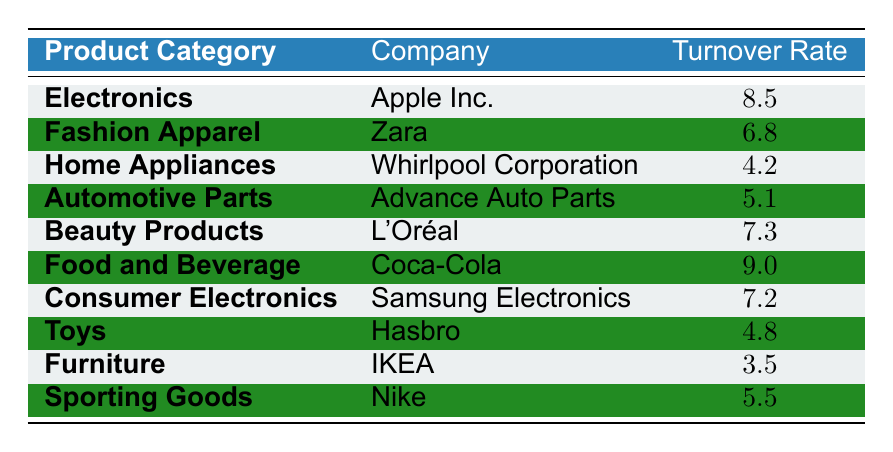What is the highest inventory turnover rate in the table? By examining the turnover rates listed in the table, the highest value is 9.0 from Coca-Cola in the Food and Beverage category.
Answer: 9.0 Which company has the lowest inventory turnover rate? The table shows that IKEA has the lowest turnover rate of 3.5 in the Furniture category.
Answer: IKEA What is the average inventory turnover rate for the product categories listed? To find the average, sum all the turnover rates (8.5 + 6.8 + 4.2 + 5.1 + 7.3 + 9.0 + 7.2 + 4.8 + 3.5 + 5.5) = 57.4, then divide by the number of categories (10). The average is 57.4 / 10 = 5.74.
Answer: 5.74 Does Zara have a higher inventory turnover rate than Whirlpool Corporation? Yes, Zara's turnover rate is 6.8, which is higher than Whirlpool Corporation's 4.2.
Answer: Yes What is the difference in turnover rate between the company with the highest and the lowest rates? The highest turnover rate is Coca-Cola at 9.0 and the lowest is IKEA at 3.5. The difference is 9.0 - 3.5 = 5.5.
Answer: 5.5 How many product categories have a turnover rate greater than 6? The product categories with rates greater than 6 are Electronics (8.5), Fashion Apparel (6.8), Beauty Products (7.3), Food and Beverage (9.0), and Consumer Electronics (7.2), counting to 5 categories in total.
Answer: 5 Which two companies have turnover rates within 0.5 of each other? By examining the rates, L'Oréal at 7.3 and Samsung Electronics at 7.2 are within 0.5 of each other.
Answer: L'Oréal and Samsung Electronics What is the median inventory turnover rate based on the data? To find the median, first arrange the turnover rates in ascending order: 3.5, 4.2, 4.8, 5.1, 5.5, 6.8, 7.2, 7.3, 8.5, 9.0. The median is the average of the 5th and 6th values (5.5 + 6.8) / 2 = 6.15.
Answer: 6.15 Does any product category have an inventory turnover rate of exactly 7.0? No, checking the listed turnover rates shows that none is exactly 7.0.
Answer: No Which product category has a higher turnover rate: Home Appliances or Sporting Goods? Home Appliances have a turnover rate of 4.2, while Sporting Goods have 5.5, which is higher than Home Appliances.
Answer: Sporting Goods If we combine the turnover rates of Toys and Automotive Parts, what is the total? The turnover rates are 4.8 for Toys and 5.1 for Automotive Parts. Combining these gives 4.8 + 5.1 = 9.9.
Answer: 9.9 